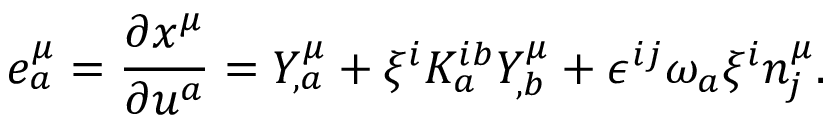Convert formula to latex. <formula><loc_0><loc_0><loc_500><loc_500>e _ { a } ^ { \mu } = \frac { \partial x ^ { \mu } } { \partial u ^ { a } } = Y _ { , a } ^ { \mu } + \xi ^ { i } K _ { a } ^ { i b } Y _ { , b } ^ { \mu } + \epsilon ^ { i j } \omega _ { a } \xi ^ { i } n _ { j } ^ { \mu } .</formula> 